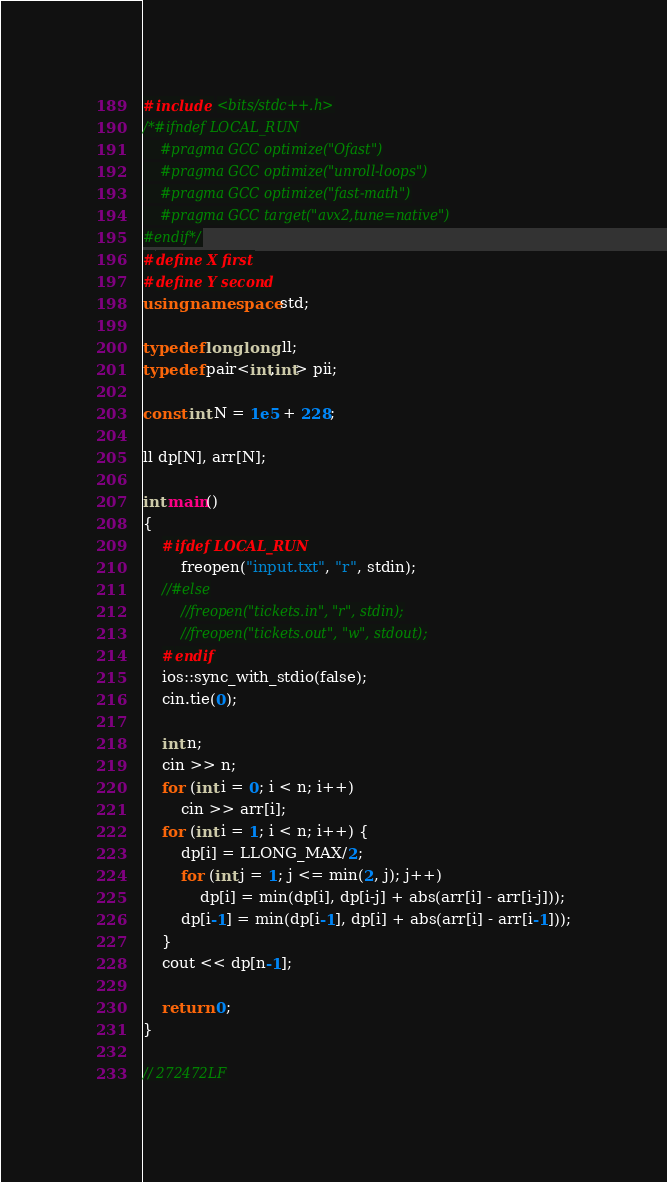Convert code to text. <code><loc_0><loc_0><loc_500><loc_500><_C++_>#include <bits/stdc++.h>
/*#ifndef LOCAL_RUN
    #pragma GCC optimize("Ofast")
    #pragma GCC optimize("unroll-loops")
    #pragma GCC optimize("fast-math")
    #pragma GCC target("avx2,tune=native")
#endif*/
#define X first
#define Y second
using namespace std;

typedef long long ll;
typedef pair<int,int> pii;

const int N = 1e5 + 228;

ll dp[N], arr[N];

int main()
{
    #ifdef LOCAL_RUN
        freopen("input.txt", "r", stdin);
    //#else
        //freopen("tickets.in", "r", stdin);
        //freopen("tickets.out", "w", stdout);
    #endif
	ios::sync_with_stdio(false);
    cin.tie(0);

    int n;
    cin >> n;
    for (int i = 0; i < n; i++)
        cin >> arr[i];
    for (int i = 1; i < n; i++) {
        dp[i] = LLONG_MAX/2;
        for (int j = 1; j <= min(2, j); j++)
            dp[i] = min(dp[i], dp[i-j] + abs(arr[i] - arr[i-j]));
        dp[i-1] = min(dp[i-1], dp[i] + abs(arr[i] - arr[i-1]));
    }
    cout << dp[n-1];

    return 0;
}

// 272472LF
</code> 